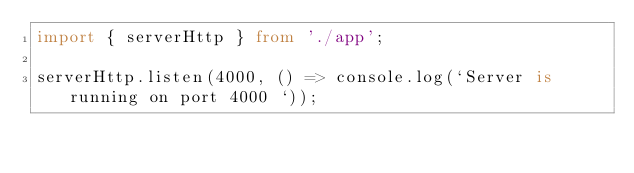<code> <loc_0><loc_0><loc_500><loc_500><_TypeScript_>import { serverHttp } from './app';

serverHttp.listen(4000, () => console.log(`Server is running on port 4000 `));
</code> 